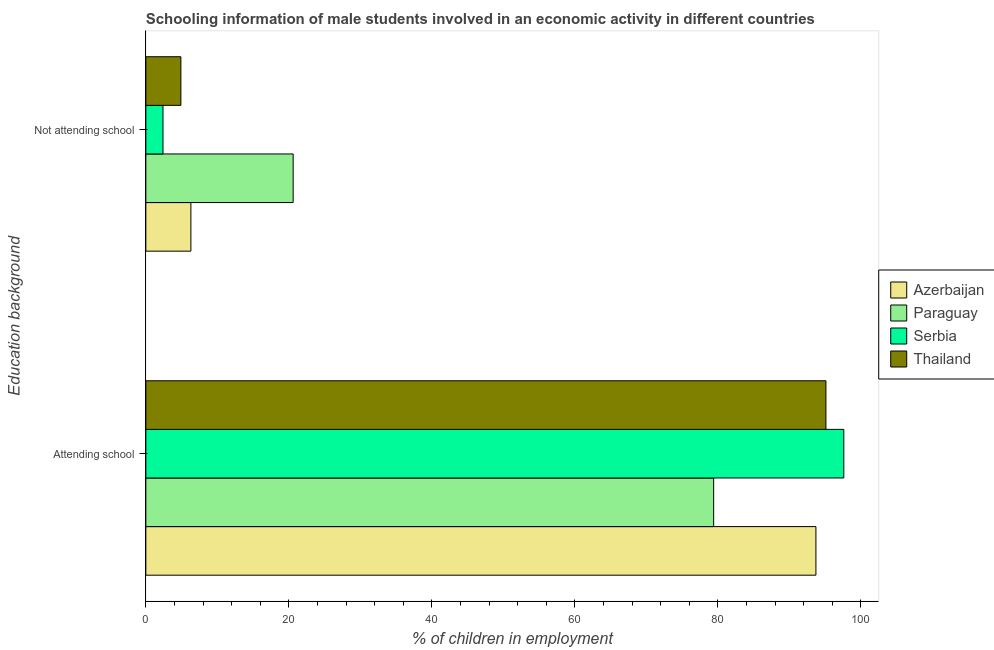How many different coloured bars are there?
Your answer should be very brief. 4. How many groups of bars are there?
Give a very brief answer. 2. Are the number of bars on each tick of the Y-axis equal?
Provide a succinct answer. Yes. How many bars are there on the 2nd tick from the top?
Provide a short and direct response. 4. How many bars are there on the 2nd tick from the bottom?
Your answer should be compact. 4. What is the label of the 1st group of bars from the top?
Provide a succinct answer. Not attending school. What is the percentage of employed males who are attending school in Thailand?
Provide a succinct answer. 95.1. Across all countries, what is the maximum percentage of employed males who are not attending school?
Your answer should be very brief. 20.6. Across all countries, what is the minimum percentage of employed males who are not attending school?
Give a very brief answer. 2.4. In which country was the percentage of employed males who are attending school maximum?
Give a very brief answer. Serbia. In which country was the percentage of employed males who are attending school minimum?
Provide a succinct answer. Paraguay. What is the total percentage of employed males who are not attending school in the graph?
Make the answer very short. 34.2. What is the difference between the percentage of employed males who are not attending school in Serbia and that in Thailand?
Your response must be concise. -2.5. What is the difference between the percentage of employed males who are attending school in Azerbaijan and the percentage of employed males who are not attending school in Paraguay?
Your response must be concise. 73.1. What is the average percentage of employed males who are not attending school per country?
Ensure brevity in your answer.  8.55. What is the difference between the percentage of employed males who are not attending school and percentage of employed males who are attending school in Azerbaijan?
Give a very brief answer. -87.4. In how many countries, is the percentage of employed males who are attending school greater than 60 %?
Your response must be concise. 4. What is the ratio of the percentage of employed males who are attending school in Azerbaijan to that in Thailand?
Ensure brevity in your answer.  0.99. Is the percentage of employed males who are attending school in Paraguay less than that in Serbia?
Your answer should be compact. Yes. In how many countries, is the percentage of employed males who are attending school greater than the average percentage of employed males who are attending school taken over all countries?
Make the answer very short. 3. What does the 1st bar from the top in Not attending school represents?
Make the answer very short. Thailand. What does the 1st bar from the bottom in Not attending school represents?
Offer a very short reply. Azerbaijan. How many countries are there in the graph?
Ensure brevity in your answer.  4. Does the graph contain grids?
Your answer should be compact. No. What is the title of the graph?
Your answer should be compact. Schooling information of male students involved in an economic activity in different countries. What is the label or title of the X-axis?
Your response must be concise. % of children in employment. What is the label or title of the Y-axis?
Ensure brevity in your answer.  Education background. What is the % of children in employment of Azerbaijan in Attending school?
Your answer should be compact. 93.7. What is the % of children in employment of Paraguay in Attending school?
Provide a short and direct response. 79.4. What is the % of children in employment in Serbia in Attending school?
Keep it short and to the point. 97.6. What is the % of children in employment of Thailand in Attending school?
Offer a very short reply. 95.1. What is the % of children in employment in Azerbaijan in Not attending school?
Your answer should be very brief. 6.3. What is the % of children in employment in Paraguay in Not attending school?
Offer a terse response. 20.6. What is the % of children in employment in Thailand in Not attending school?
Make the answer very short. 4.9. Across all Education background, what is the maximum % of children in employment in Azerbaijan?
Keep it short and to the point. 93.7. Across all Education background, what is the maximum % of children in employment in Paraguay?
Provide a short and direct response. 79.4. Across all Education background, what is the maximum % of children in employment of Serbia?
Your response must be concise. 97.6. Across all Education background, what is the maximum % of children in employment of Thailand?
Your answer should be compact. 95.1. Across all Education background, what is the minimum % of children in employment in Azerbaijan?
Offer a terse response. 6.3. Across all Education background, what is the minimum % of children in employment of Paraguay?
Keep it short and to the point. 20.6. Across all Education background, what is the minimum % of children in employment in Serbia?
Your answer should be compact. 2.4. Across all Education background, what is the minimum % of children in employment in Thailand?
Your answer should be very brief. 4.9. What is the total % of children in employment of Paraguay in the graph?
Give a very brief answer. 100. What is the total % of children in employment of Serbia in the graph?
Your answer should be very brief. 100. What is the difference between the % of children in employment in Azerbaijan in Attending school and that in Not attending school?
Your answer should be very brief. 87.4. What is the difference between the % of children in employment of Paraguay in Attending school and that in Not attending school?
Offer a very short reply. 58.8. What is the difference between the % of children in employment of Serbia in Attending school and that in Not attending school?
Provide a short and direct response. 95.2. What is the difference between the % of children in employment in Thailand in Attending school and that in Not attending school?
Provide a succinct answer. 90.2. What is the difference between the % of children in employment in Azerbaijan in Attending school and the % of children in employment in Paraguay in Not attending school?
Ensure brevity in your answer.  73.1. What is the difference between the % of children in employment in Azerbaijan in Attending school and the % of children in employment in Serbia in Not attending school?
Offer a terse response. 91.3. What is the difference between the % of children in employment in Azerbaijan in Attending school and the % of children in employment in Thailand in Not attending school?
Keep it short and to the point. 88.8. What is the difference between the % of children in employment of Paraguay in Attending school and the % of children in employment of Thailand in Not attending school?
Give a very brief answer. 74.5. What is the difference between the % of children in employment of Serbia in Attending school and the % of children in employment of Thailand in Not attending school?
Your answer should be very brief. 92.7. What is the difference between the % of children in employment of Azerbaijan and % of children in employment of Paraguay in Attending school?
Keep it short and to the point. 14.3. What is the difference between the % of children in employment in Azerbaijan and % of children in employment in Thailand in Attending school?
Give a very brief answer. -1.4. What is the difference between the % of children in employment in Paraguay and % of children in employment in Serbia in Attending school?
Your response must be concise. -18.2. What is the difference between the % of children in employment in Paraguay and % of children in employment in Thailand in Attending school?
Offer a terse response. -15.7. What is the difference between the % of children in employment of Azerbaijan and % of children in employment of Paraguay in Not attending school?
Make the answer very short. -14.3. What is the difference between the % of children in employment of Paraguay and % of children in employment of Serbia in Not attending school?
Offer a terse response. 18.2. What is the difference between the % of children in employment of Paraguay and % of children in employment of Thailand in Not attending school?
Provide a succinct answer. 15.7. What is the difference between the % of children in employment of Serbia and % of children in employment of Thailand in Not attending school?
Offer a very short reply. -2.5. What is the ratio of the % of children in employment of Azerbaijan in Attending school to that in Not attending school?
Provide a succinct answer. 14.87. What is the ratio of the % of children in employment in Paraguay in Attending school to that in Not attending school?
Provide a succinct answer. 3.85. What is the ratio of the % of children in employment in Serbia in Attending school to that in Not attending school?
Ensure brevity in your answer.  40.67. What is the ratio of the % of children in employment in Thailand in Attending school to that in Not attending school?
Ensure brevity in your answer.  19.41. What is the difference between the highest and the second highest % of children in employment of Azerbaijan?
Offer a terse response. 87.4. What is the difference between the highest and the second highest % of children in employment of Paraguay?
Offer a terse response. 58.8. What is the difference between the highest and the second highest % of children in employment of Serbia?
Offer a terse response. 95.2. What is the difference between the highest and the second highest % of children in employment of Thailand?
Offer a terse response. 90.2. What is the difference between the highest and the lowest % of children in employment of Azerbaijan?
Your answer should be very brief. 87.4. What is the difference between the highest and the lowest % of children in employment in Paraguay?
Keep it short and to the point. 58.8. What is the difference between the highest and the lowest % of children in employment in Serbia?
Give a very brief answer. 95.2. What is the difference between the highest and the lowest % of children in employment of Thailand?
Provide a succinct answer. 90.2. 